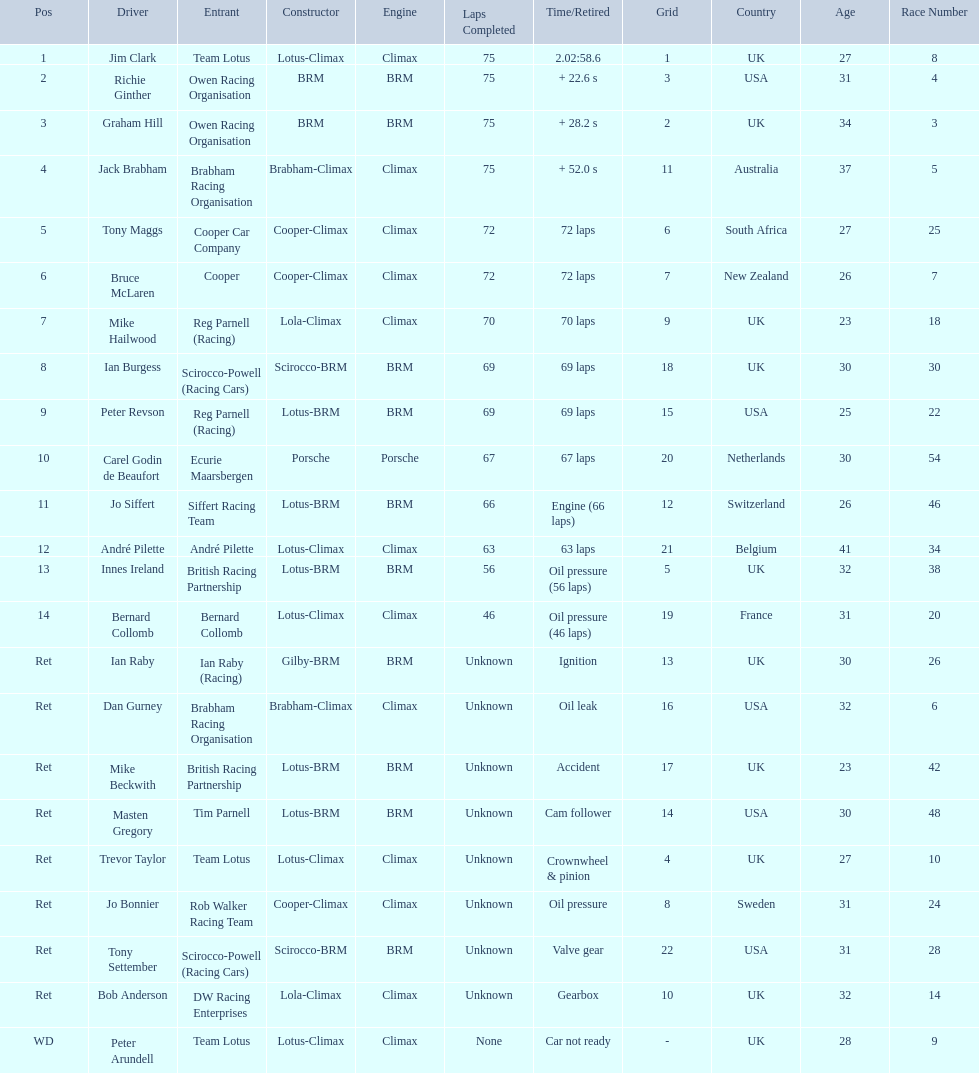Who are all the drivers? Jim Clark, Richie Ginther, Graham Hill, Jack Brabham, Tony Maggs, Bruce McLaren, Mike Hailwood, Ian Burgess, Peter Revson, Carel Godin de Beaufort, Jo Siffert, André Pilette, Innes Ireland, Bernard Collomb, Ian Raby, Dan Gurney, Mike Beckwith, Masten Gregory, Trevor Taylor, Jo Bonnier, Tony Settember, Bob Anderson, Peter Arundell. What were their positions? 1, 2, 3, 4, 5, 6, 7, 8, 9, 10, 11, 12, 13, 14, Ret, Ret, Ret, Ret, Ret, Ret, Ret, Ret, WD. What are all the constructor names? Lotus-Climax, BRM, BRM, Brabham-Climax, Cooper-Climax, Cooper-Climax, Lola-Climax, Scirocco-BRM, Lotus-BRM, Porsche, Lotus-BRM, Lotus-Climax, Lotus-BRM, Lotus-Climax, Gilby-BRM, Brabham-Climax, Lotus-BRM, Lotus-BRM, Lotus-Climax, Cooper-Climax, Scirocco-BRM, Lola-Climax, Lotus-Climax. And which drivers drove a cooper-climax? Tony Maggs, Bruce McLaren. Between those tow, who was positioned higher? Tony Maggs. 